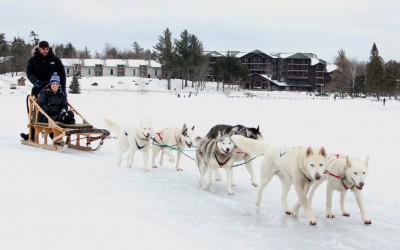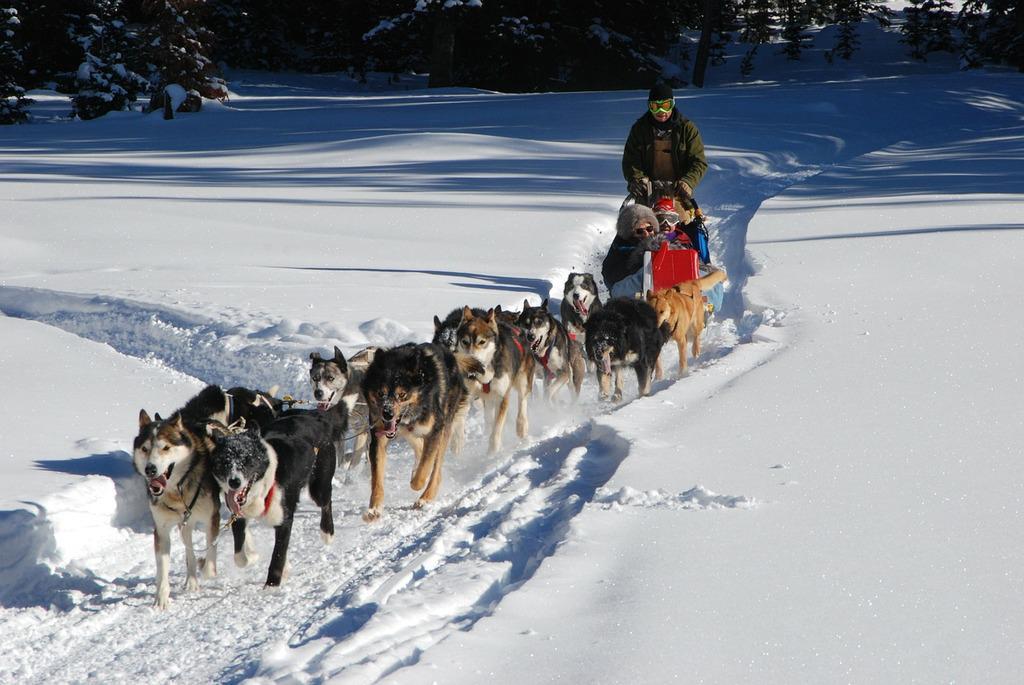The first image is the image on the left, the second image is the image on the right. For the images shown, is this caption "The dogs in both pictures are pulling the sled towards the right." true? Answer yes or no. No. The first image is the image on the left, the second image is the image on the right. For the images shown, is this caption "The dog sled teams in the left and right images move rightward at an angle over the snow and contain traditional husky-type sled dogs." true? Answer yes or no. No. 